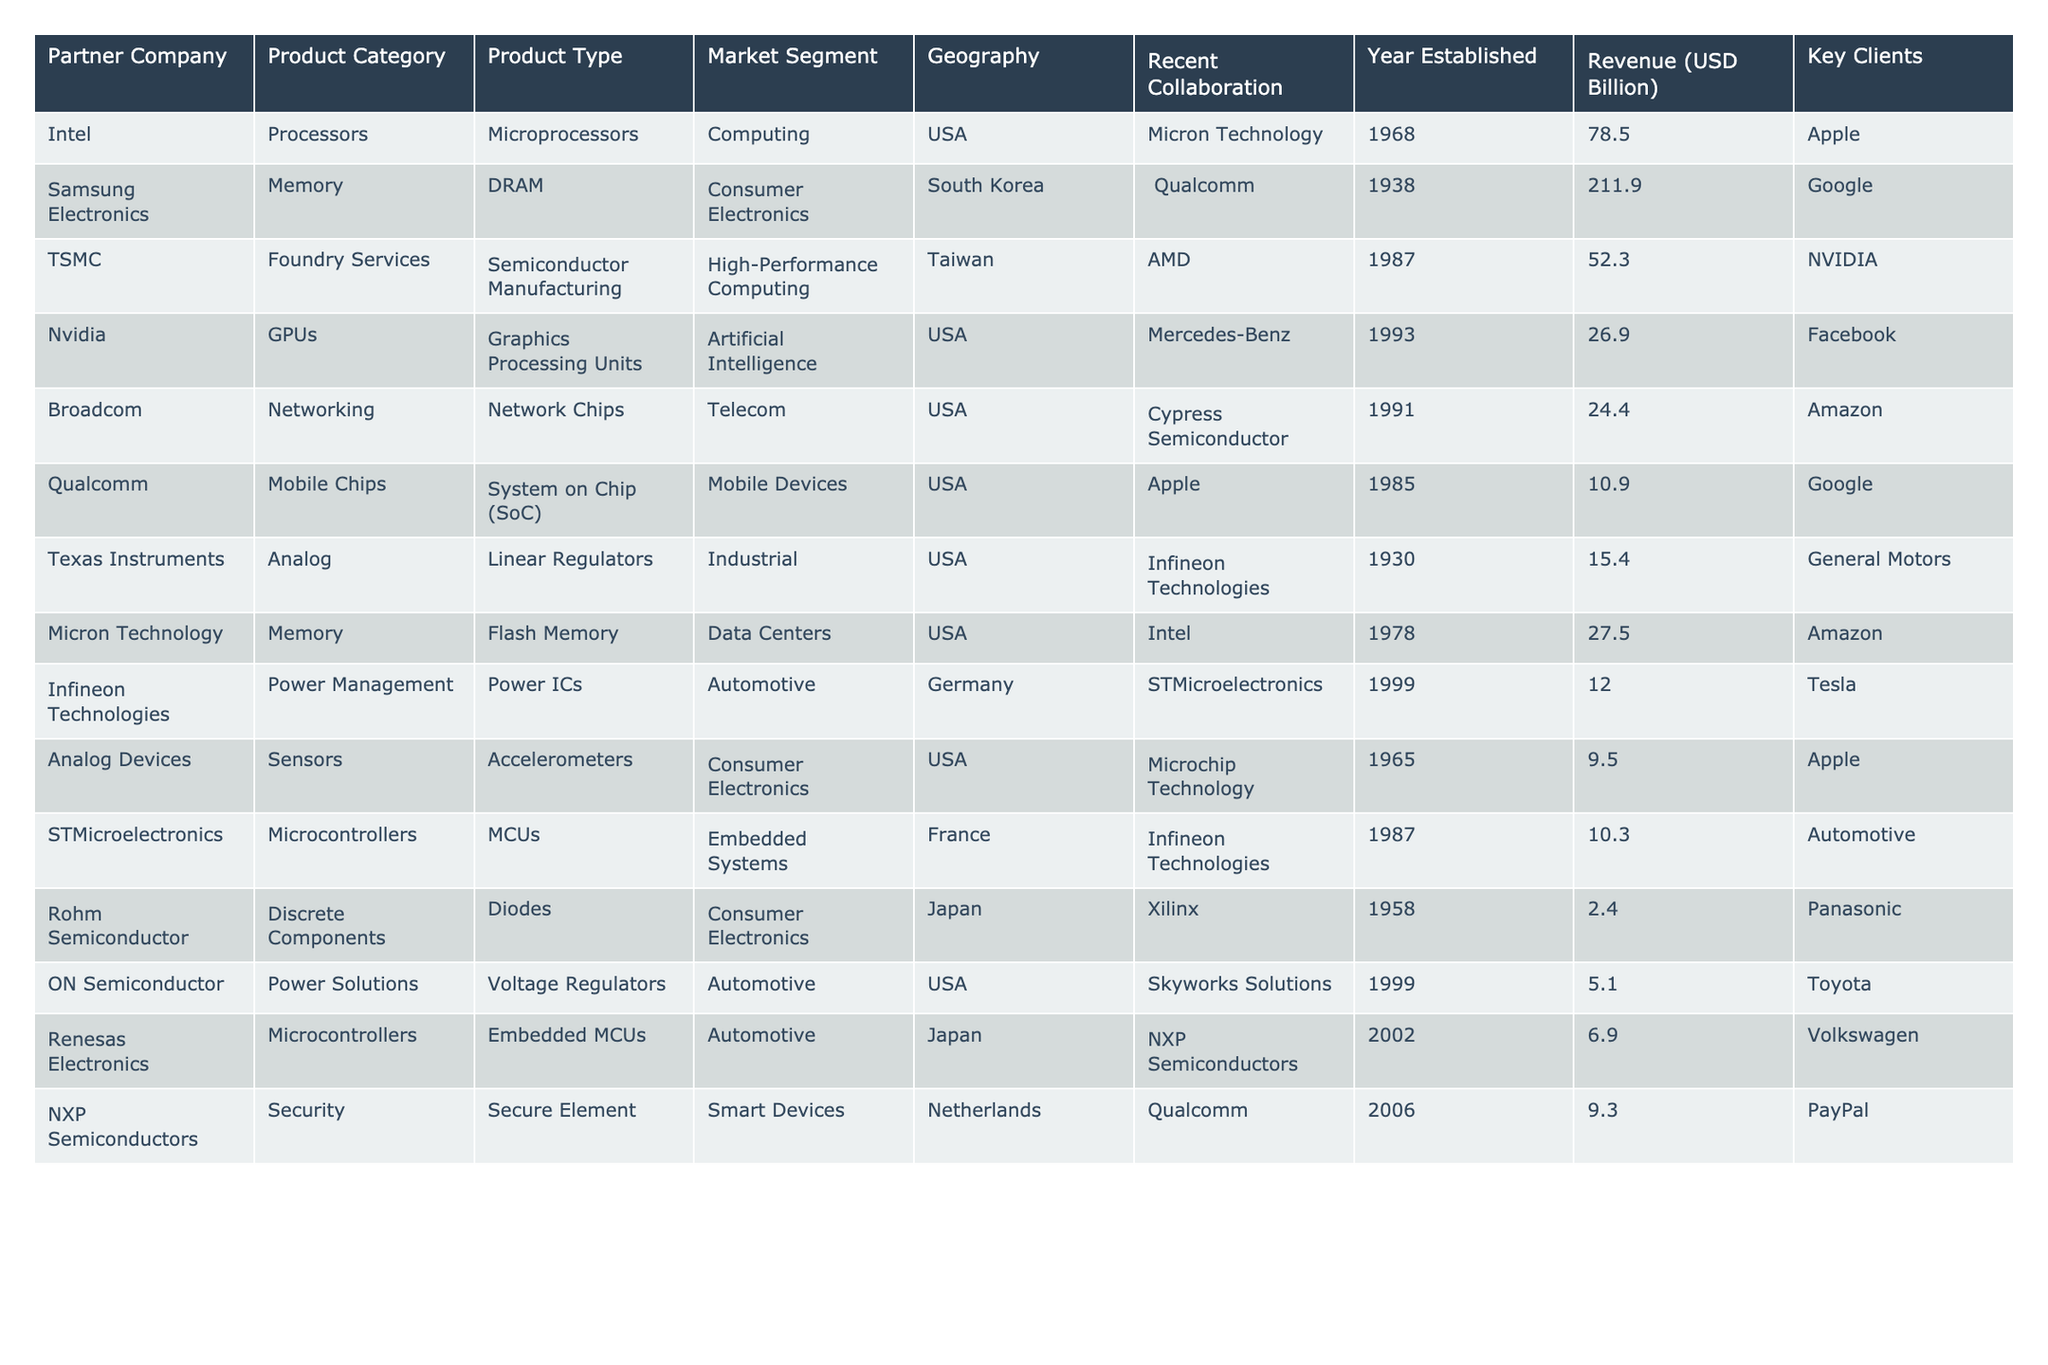What is the total revenue generated by the partners listed in the table? To find the total revenue, we sum the revenue amounts for each partner: 78.5 + 211.9 + 52.3 + 26.9 + 24.4 + 10.9 + 15.4 + 27.5 + 12.0 + 9.5 + 10.3 + 2.4 + 5.1 + 6.9 + 9.3 = 505.4
Answer: 505.4 Which partner company has the highest revenue? By examining the revenue column, Samsung Electronics has the highest revenue at 211.9 billion USD.
Answer: Samsung Electronics What product category does TSMC belong to? TSMC is listed under the product category of Foundry Services in the table.
Answer: Foundry Services Are there any partners specializing in automotive products? Yes, Infineon Technologies, ON Semiconductor, and Renesas Electronics specialize in automotive-related products.
Answer: Yes What is the average revenue of the listed semiconductor partners? The average revenue is calculated by dividing the total revenue (505.4 billion USD) by the number of partners (15). So, 505.4 / 15 = 33.69.
Answer: 33.69 Which partner’s key client is Tesla? Infineon Technologies lists Tesla as one of its key clients in the table.
Answer: Infineon Technologies How many partners operate in the USA market segment? By counting the entries from the table for the USA market segment, we find there are 7 partners: Intel, Nvidia, Broadcom, Qualcomm, Micron Technology, Analog Devices, and ON Semiconductor.
Answer: 7 Is there any partner company that has collaborated with Apple? Yes, both Intel and Qualcomm have collaborated with Apple as per the table.
Answer: Yes What geographical region is associated with the partner company Texas Instruments? Texas Instruments is associated with the USA geographical region.
Answer: USA Which partner company is involved in consumer electronics and specializes in memory products? Micron Technology specializes in Flash Memory within the consumer electronics segment.
Answer: Micron Technology What is the difference in revenue between the top revenue-generating partner and the lowest? The highest revenue is 211.9 billion USD (Samsung Electronics) and the lowest is 2.4 billion USD (Rohm Semiconductor). The difference is 211.9 - 2.4 = 209.5 billion USD.
Answer: 209.5 billion USD How many key clients does Broadcom have as listed in the table? Broadcom has one key client listed in the table: Amazon.
Answer: 1 Do any partners belong to the product type of Microcontrollers? Yes, both STMicroelectronics and Renesas Electronics are listed as producing Microcontrollers in the table.
Answer: Yes What market segment is served by Nvidia? Nvidia serves the Artificial Intelligence market segment according to the table.
Answer: Artificial Intelligence Which partner established the earliest, according to the table? Texas Instruments was established in 1930, making it the earliest partner listed in the table.
Answer: Texas Instruments 